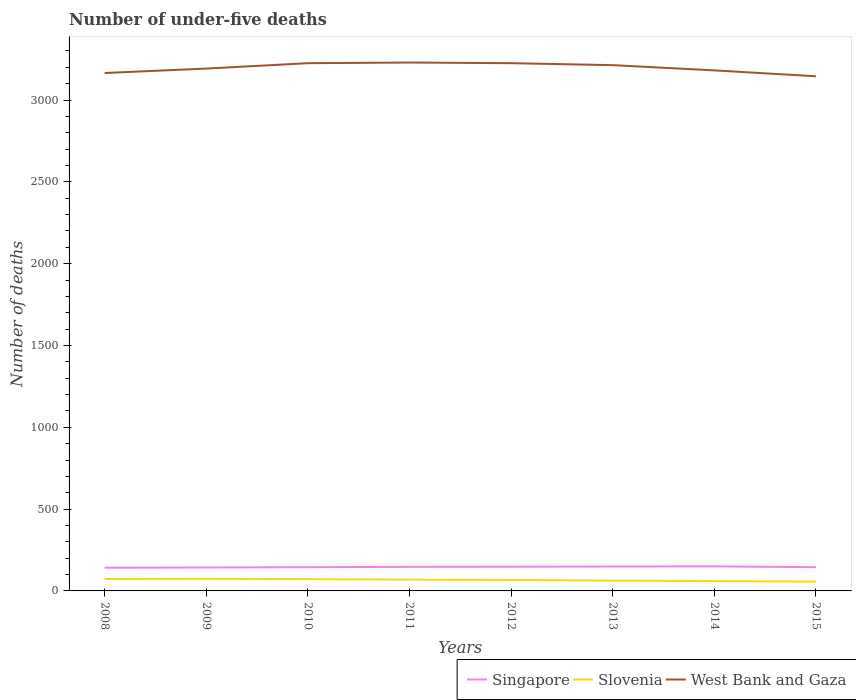How many different coloured lines are there?
Offer a terse response. 3. Is the number of lines equal to the number of legend labels?
Give a very brief answer. Yes. Across all years, what is the maximum number of under-five deaths in West Bank and Gaza?
Your answer should be very brief. 3145. In which year was the number of under-five deaths in Slovenia maximum?
Your answer should be very brief. 2015. What is the total number of under-five deaths in Slovenia in the graph?
Give a very brief answer. 9. What is the difference between the highest and the second highest number of under-five deaths in West Bank and Gaza?
Give a very brief answer. 84. Is the number of under-five deaths in Slovenia strictly greater than the number of under-five deaths in Singapore over the years?
Offer a very short reply. Yes. How many years are there in the graph?
Your answer should be compact. 8. What is the difference between two consecutive major ticks on the Y-axis?
Your answer should be compact. 500. Are the values on the major ticks of Y-axis written in scientific E-notation?
Keep it short and to the point. No. Does the graph contain grids?
Your answer should be very brief. No. Where does the legend appear in the graph?
Ensure brevity in your answer.  Bottom right. How many legend labels are there?
Give a very brief answer. 3. How are the legend labels stacked?
Provide a succinct answer. Horizontal. What is the title of the graph?
Your response must be concise. Number of under-five deaths. What is the label or title of the X-axis?
Your answer should be very brief. Years. What is the label or title of the Y-axis?
Offer a very short reply. Number of deaths. What is the Number of deaths of Singapore in 2008?
Your answer should be very brief. 142. What is the Number of deaths of Slovenia in 2008?
Give a very brief answer. 73. What is the Number of deaths of West Bank and Gaza in 2008?
Ensure brevity in your answer.  3165. What is the Number of deaths of Singapore in 2009?
Make the answer very short. 143. What is the Number of deaths of Slovenia in 2009?
Your answer should be very brief. 74. What is the Number of deaths in West Bank and Gaza in 2009?
Provide a succinct answer. 3192. What is the Number of deaths in Singapore in 2010?
Make the answer very short. 145. What is the Number of deaths of West Bank and Gaza in 2010?
Your answer should be compact. 3225. What is the Number of deaths of Singapore in 2011?
Your answer should be compact. 147. What is the Number of deaths of West Bank and Gaza in 2011?
Offer a terse response. 3229. What is the Number of deaths in Singapore in 2012?
Make the answer very short. 148. What is the Number of deaths in West Bank and Gaza in 2012?
Keep it short and to the point. 3225. What is the Number of deaths in Singapore in 2013?
Provide a short and direct response. 149. What is the Number of deaths of West Bank and Gaza in 2013?
Ensure brevity in your answer.  3213. What is the Number of deaths of Singapore in 2014?
Ensure brevity in your answer.  150. What is the Number of deaths in Slovenia in 2014?
Offer a very short reply. 60. What is the Number of deaths of West Bank and Gaza in 2014?
Ensure brevity in your answer.  3181. What is the Number of deaths of Singapore in 2015?
Make the answer very short. 145. What is the Number of deaths of West Bank and Gaza in 2015?
Your response must be concise. 3145. Across all years, what is the maximum Number of deaths of Singapore?
Give a very brief answer. 150. Across all years, what is the maximum Number of deaths in West Bank and Gaza?
Your answer should be compact. 3229. Across all years, what is the minimum Number of deaths of Singapore?
Ensure brevity in your answer.  142. Across all years, what is the minimum Number of deaths of West Bank and Gaza?
Keep it short and to the point. 3145. What is the total Number of deaths in Singapore in the graph?
Give a very brief answer. 1169. What is the total Number of deaths in Slovenia in the graph?
Give a very brief answer. 535. What is the total Number of deaths of West Bank and Gaza in the graph?
Provide a short and direct response. 2.56e+04. What is the difference between the Number of deaths of Singapore in 2008 and that in 2009?
Ensure brevity in your answer.  -1. What is the difference between the Number of deaths of West Bank and Gaza in 2008 and that in 2009?
Your answer should be compact. -27. What is the difference between the Number of deaths of Singapore in 2008 and that in 2010?
Your response must be concise. -3. What is the difference between the Number of deaths of Slovenia in 2008 and that in 2010?
Give a very brief answer. 1. What is the difference between the Number of deaths of West Bank and Gaza in 2008 and that in 2010?
Provide a short and direct response. -60. What is the difference between the Number of deaths in Slovenia in 2008 and that in 2011?
Provide a short and direct response. 4. What is the difference between the Number of deaths in West Bank and Gaza in 2008 and that in 2011?
Offer a very short reply. -64. What is the difference between the Number of deaths of West Bank and Gaza in 2008 and that in 2012?
Your answer should be compact. -60. What is the difference between the Number of deaths of West Bank and Gaza in 2008 and that in 2013?
Your answer should be very brief. -48. What is the difference between the Number of deaths of Singapore in 2008 and that in 2014?
Give a very brief answer. -8. What is the difference between the Number of deaths in Slovenia in 2008 and that in 2014?
Offer a terse response. 13. What is the difference between the Number of deaths in Singapore in 2008 and that in 2015?
Provide a succinct answer. -3. What is the difference between the Number of deaths of West Bank and Gaza in 2008 and that in 2015?
Your response must be concise. 20. What is the difference between the Number of deaths of Slovenia in 2009 and that in 2010?
Your answer should be very brief. 2. What is the difference between the Number of deaths of West Bank and Gaza in 2009 and that in 2010?
Your answer should be compact. -33. What is the difference between the Number of deaths in Slovenia in 2009 and that in 2011?
Offer a very short reply. 5. What is the difference between the Number of deaths of West Bank and Gaza in 2009 and that in 2011?
Give a very brief answer. -37. What is the difference between the Number of deaths in West Bank and Gaza in 2009 and that in 2012?
Provide a short and direct response. -33. What is the difference between the Number of deaths of Singapore in 2009 and that in 2013?
Offer a terse response. -6. What is the difference between the Number of deaths of Singapore in 2009 and that in 2014?
Provide a short and direct response. -7. What is the difference between the Number of deaths in West Bank and Gaza in 2009 and that in 2014?
Your answer should be very brief. 11. What is the difference between the Number of deaths of Slovenia in 2009 and that in 2015?
Provide a succinct answer. 17. What is the difference between the Number of deaths of Singapore in 2010 and that in 2011?
Your response must be concise. -2. What is the difference between the Number of deaths of Slovenia in 2010 and that in 2012?
Provide a succinct answer. 5. What is the difference between the Number of deaths in Slovenia in 2010 and that in 2015?
Offer a terse response. 15. What is the difference between the Number of deaths of Singapore in 2011 and that in 2012?
Offer a terse response. -1. What is the difference between the Number of deaths of Slovenia in 2011 and that in 2012?
Ensure brevity in your answer.  2. What is the difference between the Number of deaths in West Bank and Gaza in 2011 and that in 2012?
Your answer should be compact. 4. What is the difference between the Number of deaths in Slovenia in 2011 and that in 2013?
Your response must be concise. 6. What is the difference between the Number of deaths in West Bank and Gaza in 2011 and that in 2013?
Ensure brevity in your answer.  16. What is the difference between the Number of deaths of West Bank and Gaza in 2011 and that in 2014?
Provide a short and direct response. 48. What is the difference between the Number of deaths in Singapore in 2012 and that in 2013?
Your answer should be very brief. -1. What is the difference between the Number of deaths of Slovenia in 2012 and that in 2013?
Make the answer very short. 4. What is the difference between the Number of deaths in West Bank and Gaza in 2012 and that in 2013?
Your answer should be very brief. 12. What is the difference between the Number of deaths of Singapore in 2012 and that in 2014?
Give a very brief answer. -2. What is the difference between the Number of deaths of Singapore in 2012 and that in 2015?
Make the answer very short. 3. What is the difference between the Number of deaths of Slovenia in 2012 and that in 2015?
Your answer should be compact. 10. What is the difference between the Number of deaths of Singapore in 2013 and that in 2014?
Offer a terse response. -1. What is the difference between the Number of deaths in West Bank and Gaza in 2013 and that in 2014?
Offer a terse response. 32. What is the difference between the Number of deaths of Singapore in 2013 and that in 2015?
Keep it short and to the point. 4. What is the difference between the Number of deaths of Slovenia in 2014 and that in 2015?
Your answer should be compact. 3. What is the difference between the Number of deaths in Singapore in 2008 and the Number of deaths in Slovenia in 2009?
Keep it short and to the point. 68. What is the difference between the Number of deaths of Singapore in 2008 and the Number of deaths of West Bank and Gaza in 2009?
Keep it short and to the point. -3050. What is the difference between the Number of deaths in Slovenia in 2008 and the Number of deaths in West Bank and Gaza in 2009?
Provide a succinct answer. -3119. What is the difference between the Number of deaths in Singapore in 2008 and the Number of deaths in West Bank and Gaza in 2010?
Give a very brief answer. -3083. What is the difference between the Number of deaths in Slovenia in 2008 and the Number of deaths in West Bank and Gaza in 2010?
Provide a short and direct response. -3152. What is the difference between the Number of deaths in Singapore in 2008 and the Number of deaths in West Bank and Gaza in 2011?
Give a very brief answer. -3087. What is the difference between the Number of deaths in Slovenia in 2008 and the Number of deaths in West Bank and Gaza in 2011?
Offer a terse response. -3156. What is the difference between the Number of deaths of Singapore in 2008 and the Number of deaths of Slovenia in 2012?
Make the answer very short. 75. What is the difference between the Number of deaths in Singapore in 2008 and the Number of deaths in West Bank and Gaza in 2012?
Provide a short and direct response. -3083. What is the difference between the Number of deaths of Slovenia in 2008 and the Number of deaths of West Bank and Gaza in 2012?
Give a very brief answer. -3152. What is the difference between the Number of deaths of Singapore in 2008 and the Number of deaths of Slovenia in 2013?
Offer a terse response. 79. What is the difference between the Number of deaths of Singapore in 2008 and the Number of deaths of West Bank and Gaza in 2013?
Your response must be concise. -3071. What is the difference between the Number of deaths in Slovenia in 2008 and the Number of deaths in West Bank and Gaza in 2013?
Your response must be concise. -3140. What is the difference between the Number of deaths of Singapore in 2008 and the Number of deaths of West Bank and Gaza in 2014?
Make the answer very short. -3039. What is the difference between the Number of deaths in Slovenia in 2008 and the Number of deaths in West Bank and Gaza in 2014?
Your answer should be very brief. -3108. What is the difference between the Number of deaths of Singapore in 2008 and the Number of deaths of West Bank and Gaza in 2015?
Keep it short and to the point. -3003. What is the difference between the Number of deaths in Slovenia in 2008 and the Number of deaths in West Bank and Gaza in 2015?
Your answer should be very brief. -3072. What is the difference between the Number of deaths of Singapore in 2009 and the Number of deaths of Slovenia in 2010?
Provide a succinct answer. 71. What is the difference between the Number of deaths in Singapore in 2009 and the Number of deaths in West Bank and Gaza in 2010?
Provide a short and direct response. -3082. What is the difference between the Number of deaths of Slovenia in 2009 and the Number of deaths of West Bank and Gaza in 2010?
Your answer should be compact. -3151. What is the difference between the Number of deaths of Singapore in 2009 and the Number of deaths of Slovenia in 2011?
Offer a terse response. 74. What is the difference between the Number of deaths in Singapore in 2009 and the Number of deaths in West Bank and Gaza in 2011?
Provide a succinct answer. -3086. What is the difference between the Number of deaths in Slovenia in 2009 and the Number of deaths in West Bank and Gaza in 2011?
Ensure brevity in your answer.  -3155. What is the difference between the Number of deaths in Singapore in 2009 and the Number of deaths in Slovenia in 2012?
Your answer should be very brief. 76. What is the difference between the Number of deaths in Singapore in 2009 and the Number of deaths in West Bank and Gaza in 2012?
Your answer should be compact. -3082. What is the difference between the Number of deaths in Slovenia in 2009 and the Number of deaths in West Bank and Gaza in 2012?
Your answer should be very brief. -3151. What is the difference between the Number of deaths of Singapore in 2009 and the Number of deaths of Slovenia in 2013?
Your response must be concise. 80. What is the difference between the Number of deaths in Singapore in 2009 and the Number of deaths in West Bank and Gaza in 2013?
Your answer should be compact. -3070. What is the difference between the Number of deaths in Slovenia in 2009 and the Number of deaths in West Bank and Gaza in 2013?
Ensure brevity in your answer.  -3139. What is the difference between the Number of deaths of Singapore in 2009 and the Number of deaths of West Bank and Gaza in 2014?
Give a very brief answer. -3038. What is the difference between the Number of deaths of Slovenia in 2009 and the Number of deaths of West Bank and Gaza in 2014?
Your answer should be very brief. -3107. What is the difference between the Number of deaths of Singapore in 2009 and the Number of deaths of West Bank and Gaza in 2015?
Provide a short and direct response. -3002. What is the difference between the Number of deaths in Slovenia in 2009 and the Number of deaths in West Bank and Gaza in 2015?
Your answer should be very brief. -3071. What is the difference between the Number of deaths of Singapore in 2010 and the Number of deaths of West Bank and Gaza in 2011?
Ensure brevity in your answer.  -3084. What is the difference between the Number of deaths in Slovenia in 2010 and the Number of deaths in West Bank and Gaza in 2011?
Give a very brief answer. -3157. What is the difference between the Number of deaths in Singapore in 2010 and the Number of deaths in Slovenia in 2012?
Keep it short and to the point. 78. What is the difference between the Number of deaths of Singapore in 2010 and the Number of deaths of West Bank and Gaza in 2012?
Offer a terse response. -3080. What is the difference between the Number of deaths in Slovenia in 2010 and the Number of deaths in West Bank and Gaza in 2012?
Give a very brief answer. -3153. What is the difference between the Number of deaths in Singapore in 2010 and the Number of deaths in West Bank and Gaza in 2013?
Keep it short and to the point. -3068. What is the difference between the Number of deaths in Slovenia in 2010 and the Number of deaths in West Bank and Gaza in 2013?
Offer a terse response. -3141. What is the difference between the Number of deaths of Singapore in 2010 and the Number of deaths of West Bank and Gaza in 2014?
Provide a short and direct response. -3036. What is the difference between the Number of deaths in Slovenia in 2010 and the Number of deaths in West Bank and Gaza in 2014?
Your answer should be very brief. -3109. What is the difference between the Number of deaths in Singapore in 2010 and the Number of deaths in Slovenia in 2015?
Make the answer very short. 88. What is the difference between the Number of deaths of Singapore in 2010 and the Number of deaths of West Bank and Gaza in 2015?
Make the answer very short. -3000. What is the difference between the Number of deaths of Slovenia in 2010 and the Number of deaths of West Bank and Gaza in 2015?
Your answer should be very brief. -3073. What is the difference between the Number of deaths of Singapore in 2011 and the Number of deaths of Slovenia in 2012?
Make the answer very short. 80. What is the difference between the Number of deaths in Singapore in 2011 and the Number of deaths in West Bank and Gaza in 2012?
Ensure brevity in your answer.  -3078. What is the difference between the Number of deaths in Slovenia in 2011 and the Number of deaths in West Bank and Gaza in 2012?
Make the answer very short. -3156. What is the difference between the Number of deaths in Singapore in 2011 and the Number of deaths in Slovenia in 2013?
Your answer should be very brief. 84. What is the difference between the Number of deaths of Singapore in 2011 and the Number of deaths of West Bank and Gaza in 2013?
Your answer should be compact. -3066. What is the difference between the Number of deaths in Slovenia in 2011 and the Number of deaths in West Bank and Gaza in 2013?
Provide a succinct answer. -3144. What is the difference between the Number of deaths in Singapore in 2011 and the Number of deaths in West Bank and Gaza in 2014?
Ensure brevity in your answer.  -3034. What is the difference between the Number of deaths in Slovenia in 2011 and the Number of deaths in West Bank and Gaza in 2014?
Give a very brief answer. -3112. What is the difference between the Number of deaths of Singapore in 2011 and the Number of deaths of Slovenia in 2015?
Give a very brief answer. 90. What is the difference between the Number of deaths in Singapore in 2011 and the Number of deaths in West Bank and Gaza in 2015?
Your response must be concise. -2998. What is the difference between the Number of deaths of Slovenia in 2011 and the Number of deaths of West Bank and Gaza in 2015?
Ensure brevity in your answer.  -3076. What is the difference between the Number of deaths in Singapore in 2012 and the Number of deaths in West Bank and Gaza in 2013?
Keep it short and to the point. -3065. What is the difference between the Number of deaths of Slovenia in 2012 and the Number of deaths of West Bank and Gaza in 2013?
Your response must be concise. -3146. What is the difference between the Number of deaths of Singapore in 2012 and the Number of deaths of West Bank and Gaza in 2014?
Provide a short and direct response. -3033. What is the difference between the Number of deaths in Slovenia in 2012 and the Number of deaths in West Bank and Gaza in 2014?
Offer a terse response. -3114. What is the difference between the Number of deaths of Singapore in 2012 and the Number of deaths of Slovenia in 2015?
Make the answer very short. 91. What is the difference between the Number of deaths in Singapore in 2012 and the Number of deaths in West Bank and Gaza in 2015?
Your answer should be very brief. -2997. What is the difference between the Number of deaths in Slovenia in 2012 and the Number of deaths in West Bank and Gaza in 2015?
Ensure brevity in your answer.  -3078. What is the difference between the Number of deaths of Singapore in 2013 and the Number of deaths of Slovenia in 2014?
Your answer should be very brief. 89. What is the difference between the Number of deaths of Singapore in 2013 and the Number of deaths of West Bank and Gaza in 2014?
Give a very brief answer. -3032. What is the difference between the Number of deaths in Slovenia in 2013 and the Number of deaths in West Bank and Gaza in 2014?
Offer a terse response. -3118. What is the difference between the Number of deaths of Singapore in 2013 and the Number of deaths of Slovenia in 2015?
Offer a very short reply. 92. What is the difference between the Number of deaths in Singapore in 2013 and the Number of deaths in West Bank and Gaza in 2015?
Ensure brevity in your answer.  -2996. What is the difference between the Number of deaths in Slovenia in 2013 and the Number of deaths in West Bank and Gaza in 2015?
Offer a very short reply. -3082. What is the difference between the Number of deaths in Singapore in 2014 and the Number of deaths in Slovenia in 2015?
Your response must be concise. 93. What is the difference between the Number of deaths in Singapore in 2014 and the Number of deaths in West Bank and Gaza in 2015?
Give a very brief answer. -2995. What is the difference between the Number of deaths of Slovenia in 2014 and the Number of deaths of West Bank and Gaza in 2015?
Give a very brief answer. -3085. What is the average Number of deaths in Singapore per year?
Your response must be concise. 146.12. What is the average Number of deaths in Slovenia per year?
Make the answer very short. 66.88. What is the average Number of deaths in West Bank and Gaza per year?
Offer a terse response. 3196.88. In the year 2008, what is the difference between the Number of deaths in Singapore and Number of deaths in Slovenia?
Provide a short and direct response. 69. In the year 2008, what is the difference between the Number of deaths in Singapore and Number of deaths in West Bank and Gaza?
Your answer should be very brief. -3023. In the year 2008, what is the difference between the Number of deaths of Slovenia and Number of deaths of West Bank and Gaza?
Keep it short and to the point. -3092. In the year 2009, what is the difference between the Number of deaths in Singapore and Number of deaths in West Bank and Gaza?
Your answer should be very brief. -3049. In the year 2009, what is the difference between the Number of deaths of Slovenia and Number of deaths of West Bank and Gaza?
Keep it short and to the point. -3118. In the year 2010, what is the difference between the Number of deaths in Singapore and Number of deaths in West Bank and Gaza?
Ensure brevity in your answer.  -3080. In the year 2010, what is the difference between the Number of deaths of Slovenia and Number of deaths of West Bank and Gaza?
Your answer should be compact. -3153. In the year 2011, what is the difference between the Number of deaths of Singapore and Number of deaths of West Bank and Gaza?
Your response must be concise. -3082. In the year 2011, what is the difference between the Number of deaths of Slovenia and Number of deaths of West Bank and Gaza?
Offer a terse response. -3160. In the year 2012, what is the difference between the Number of deaths of Singapore and Number of deaths of Slovenia?
Provide a short and direct response. 81. In the year 2012, what is the difference between the Number of deaths of Singapore and Number of deaths of West Bank and Gaza?
Offer a very short reply. -3077. In the year 2012, what is the difference between the Number of deaths in Slovenia and Number of deaths in West Bank and Gaza?
Provide a short and direct response. -3158. In the year 2013, what is the difference between the Number of deaths in Singapore and Number of deaths in West Bank and Gaza?
Provide a short and direct response. -3064. In the year 2013, what is the difference between the Number of deaths in Slovenia and Number of deaths in West Bank and Gaza?
Keep it short and to the point. -3150. In the year 2014, what is the difference between the Number of deaths in Singapore and Number of deaths in West Bank and Gaza?
Make the answer very short. -3031. In the year 2014, what is the difference between the Number of deaths in Slovenia and Number of deaths in West Bank and Gaza?
Offer a very short reply. -3121. In the year 2015, what is the difference between the Number of deaths of Singapore and Number of deaths of Slovenia?
Give a very brief answer. 88. In the year 2015, what is the difference between the Number of deaths of Singapore and Number of deaths of West Bank and Gaza?
Your answer should be compact. -3000. In the year 2015, what is the difference between the Number of deaths in Slovenia and Number of deaths in West Bank and Gaza?
Your response must be concise. -3088. What is the ratio of the Number of deaths in Singapore in 2008 to that in 2009?
Offer a terse response. 0.99. What is the ratio of the Number of deaths in Slovenia in 2008 to that in 2009?
Your response must be concise. 0.99. What is the ratio of the Number of deaths in West Bank and Gaza in 2008 to that in 2009?
Offer a very short reply. 0.99. What is the ratio of the Number of deaths in Singapore in 2008 to that in 2010?
Keep it short and to the point. 0.98. What is the ratio of the Number of deaths of Slovenia in 2008 to that in 2010?
Offer a very short reply. 1.01. What is the ratio of the Number of deaths in West Bank and Gaza in 2008 to that in 2010?
Your answer should be very brief. 0.98. What is the ratio of the Number of deaths in Singapore in 2008 to that in 2011?
Offer a terse response. 0.97. What is the ratio of the Number of deaths of Slovenia in 2008 to that in 2011?
Provide a short and direct response. 1.06. What is the ratio of the Number of deaths in West Bank and Gaza in 2008 to that in 2011?
Make the answer very short. 0.98. What is the ratio of the Number of deaths of Singapore in 2008 to that in 2012?
Give a very brief answer. 0.96. What is the ratio of the Number of deaths of Slovenia in 2008 to that in 2012?
Provide a short and direct response. 1.09. What is the ratio of the Number of deaths of West Bank and Gaza in 2008 to that in 2012?
Your answer should be very brief. 0.98. What is the ratio of the Number of deaths in Singapore in 2008 to that in 2013?
Keep it short and to the point. 0.95. What is the ratio of the Number of deaths in Slovenia in 2008 to that in 2013?
Provide a succinct answer. 1.16. What is the ratio of the Number of deaths in West Bank and Gaza in 2008 to that in 2013?
Make the answer very short. 0.99. What is the ratio of the Number of deaths in Singapore in 2008 to that in 2014?
Offer a very short reply. 0.95. What is the ratio of the Number of deaths of Slovenia in 2008 to that in 2014?
Provide a succinct answer. 1.22. What is the ratio of the Number of deaths in West Bank and Gaza in 2008 to that in 2014?
Offer a very short reply. 0.99. What is the ratio of the Number of deaths of Singapore in 2008 to that in 2015?
Keep it short and to the point. 0.98. What is the ratio of the Number of deaths in Slovenia in 2008 to that in 2015?
Your response must be concise. 1.28. What is the ratio of the Number of deaths of West Bank and Gaza in 2008 to that in 2015?
Make the answer very short. 1.01. What is the ratio of the Number of deaths in Singapore in 2009 to that in 2010?
Offer a terse response. 0.99. What is the ratio of the Number of deaths in Slovenia in 2009 to that in 2010?
Your response must be concise. 1.03. What is the ratio of the Number of deaths of West Bank and Gaza in 2009 to that in 2010?
Make the answer very short. 0.99. What is the ratio of the Number of deaths of Singapore in 2009 to that in 2011?
Make the answer very short. 0.97. What is the ratio of the Number of deaths of Slovenia in 2009 to that in 2011?
Ensure brevity in your answer.  1.07. What is the ratio of the Number of deaths in West Bank and Gaza in 2009 to that in 2011?
Give a very brief answer. 0.99. What is the ratio of the Number of deaths in Singapore in 2009 to that in 2012?
Make the answer very short. 0.97. What is the ratio of the Number of deaths in Slovenia in 2009 to that in 2012?
Your answer should be compact. 1.1. What is the ratio of the Number of deaths in West Bank and Gaza in 2009 to that in 2012?
Your response must be concise. 0.99. What is the ratio of the Number of deaths of Singapore in 2009 to that in 2013?
Your answer should be very brief. 0.96. What is the ratio of the Number of deaths in Slovenia in 2009 to that in 2013?
Your answer should be compact. 1.17. What is the ratio of the Number of deaths of Singapore in 2009 to that in 2014?
Make the answer very short. 0.95. What is the ratio of the Number of deaths in Slovenia in 2009 to that in 2014?
Provide a succinct answer. 1.23. What is the ratio of the Number of deaths of Singapore in 2009 to that in 2015?
Make the answer very short. 0.99. What is the ratio of the Number of deaths of Slovenia in 2009 to that in 2015?
Provide a short and direct response. 1.3. What is the ratio of the Number of deaths in West Bank and Gaza in 2009 to that in 2015?
Offer a terse response. 1.01. What is the ratio of the Number of deaths of Singapore in 2010 to that in 2011?
Offer a terse response. 0.99. What is the ratio of the Number of deaths of Slovenia in 2010 to that in 2011?
Your answer should be compact. 1.04. What is the ratio of the Number of deaths in West Bank and Gaza in 2010 to that in 2011?
Provide a succinct answer. 1. What is the ratio of the Number of deaths of Singapore in 2010 to that in 2012?
Your answer should be compact. 0.98. What is the ratio of the Number of deaths of Slovenia in 2010 to that in 2012?
Offer a terse response. 1.07. What is the ratio of the Number of deaths of Singapore in 2010 to that in 2013?
Your response must be concise. 0.97. What is the ratio of the Number of deaths in Singapore in 2010 to that in 2014?
Provide a short and direct response. 0.97. What is the ratio of the Number of deaths in West Bank and Gaza in 2010 to that in 2014?
Give a very brief answer. 1.01. What is the ratio of the Number of deaths of Slovenia in 2010 to that in 2015?
Keep it short and to the point. 1.26. What is the ratio of the Number of deaths of West Bank and Gaza in 2010 to that in 2015?
Offer a terse response. 1.03. What is the ratio of the Number of deaths in Slovenia in 2011 to that in 2012?
Offer a terse response. 1.03. What is the ratio of the Number of deaths in Singapore in 2011 to that in 2013?
Give a very brief answer. 0.99. What is the ratio of the Number of deaths of Slovenia in 2011 to that in 2013?
Keep it short and to the point. 1.1. What is the ratio of the Number of deaths of West Bank and Gaza in 2011 to that in 2013?
Offer a terse response. 1. What is the ratio of the Number of deaths in Slovenia in 2011 to that in 2014?
Offer a very short reply. 1.15. What is the ratio of the Number of deaths in West Bank and Gaza in 2011 to that in 2014?
Your answer should be very brief. 1.02. What is the ratio of the Number of deaths in Singapore in 2011 to that in 2015?
Offer a very short reply. 1.01. What is the ratio of the Number of deaths in Slovenia in 2011 to that in 2015?
Your answer should be very brief. 1.21. What is the ratio of the Number of deaths of West Bank and Gaza in 2011 to that in 2015?
Offer a terse response. 1.03. What is the ratio of the Number of deaths in Singapore in 2012 to that in 2013?
Make the answer very short. 0.99. What is the ratio of the Number of deaths in Slovenia in 2012 to that in 2013?
Provide a short and direct response. 1.06. What is the ratio of the Number of deaths in Singapore in 2012 to that in 2014?
Provide a succinct answer. 0.99. What is the ratio of the Number of deaths of Slovenia in 2012 to that in 2014?
Make the answer very short. 1.12. What is the ratio of the Number of deaths of West Bank and Gaza in 2012 to that in 2014?
Ensure brevity in your answer.  1.01. What is the ratio of the Number of deaths in Singapore in 2012 to that in 2015?
Make the answer very short. 1.02. What is the ratio of the Number of deaths of Slovenia in 2012 to that in 2015?
Your response must be concise. 1.18. What is the ratio of the Number of deaths in West Bank and Gaza in 2012 to that in 2015?
Your response must be concise. 1.03. What is the ratio of the Number of deaths in Slovenia in 2013 to that in 2014?
Your answer should be very brief. 1.05. What is the ratio of the Number of deaths in Singapore in 2013 to that in 2015?
Your response must be concise. 1.03. What is the ratio of the Number of deaths of Slovenia in 2013 to that in 2015?
Give a very brief answer. 1.11. What is the ratio of the Number of deaths in West Bank and Gaza in 2013 to that in 2015?
Provide a succinct answer. 1.02. What is the ratio of the Number of deaths in Singapore in 2014 to that in 2015?
Your response must be concise. 1.03. What is the ratio of the Number of deaths in Slovenia in 2014 to that in 2015?
Your answer should be compact. 1.05. What is the ratio of the Number of deaths in West Bank and Gaza in 2014 to that in 2015?
Make the answer very short. 1.01. What is the difference between the highest and the second highest Number of deaths in Slovenia?
Keep it short and to the point. 1. What is the difference between the highest and the second highest Number of deaths in West Bank and Gaza?
Make the answer very short. 4. 